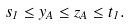Convert formula to latex. <formula><loc_0><loc_0><loc_500><loc_500>s _ { 1 } \leq y _ { A } \leq z _ { A } \leq t _ { 1 } .</formula> 